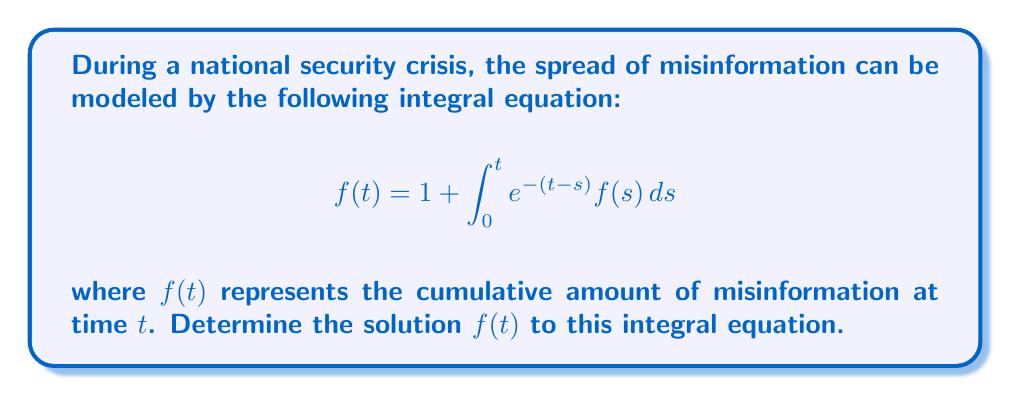Show me your answer to this math problem. To solve this integral equation, we'll follow these steps:

1) First, let's differentiate both sides of the equation with respect to $t$:

   $$f'(t) = \frac{d}{dt}\left(1 + \int_0^t e^{-(t-s)} f(s) ds\right)$$

2) Using the Leibniz integral rule:

   $$f'(t) = e^{-(t-t)}f(t) + \int_0^t \frac{\partial}{\partial t}[e^{-(t-s)}] f(s) ds$$

3) Simplify:

   $$f'(t) = f(t) - \int_0^t e^{-(t-s)} f(s) ds$$

4) From the original equation, we can substitute for the integral:

   $$f'(t) = f(t) - (f(t) - 1) = 1$$

5) We now have a simple differential equation:

   $$f'(t) = 1$$

6) Integrate both sides:

   $$f(t) = t + C$$

7) To find $C$, use the initial condition from the original equation. When $t=0$:

   $$f(0) = 1 + \int_0^0 e^{-(0-s)} f(s) ds = 1$$

   So, $0 + C = 1$, therefore $C = 1$

8) The final solution is:

   $$f(t) = t + 1$$

9) We can verify this solution by substituting it back into the original equation:

   $$t + 1 = 1 + \int_0^t e^{-(t-s)} (s + 1) ds$$

   $$t = \int_0^t e^{-(t-s)} (s + 1) ds$$

   This equality holds, confirming our solution.
Answer: $f(t) = t + 1$ 